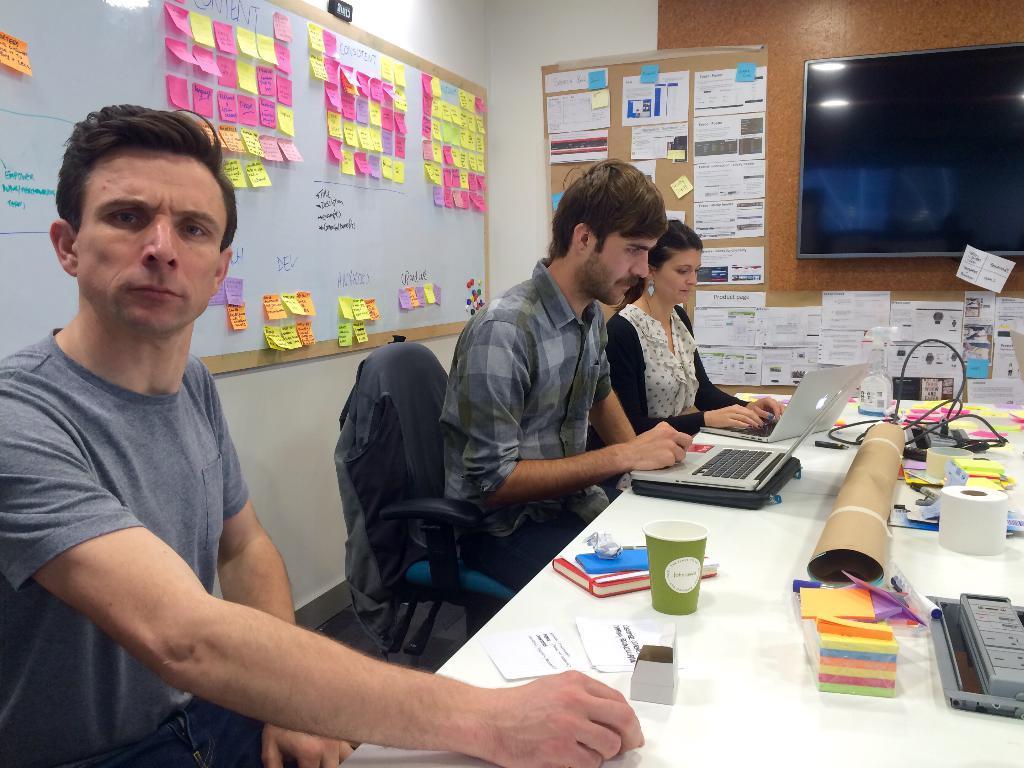How would you summarize this image in a sentence or two? As we can see in the image there are three people sitting on chairs, screen, posters, white color wall and a table. On table there are papers, books, laptops and a wire. 